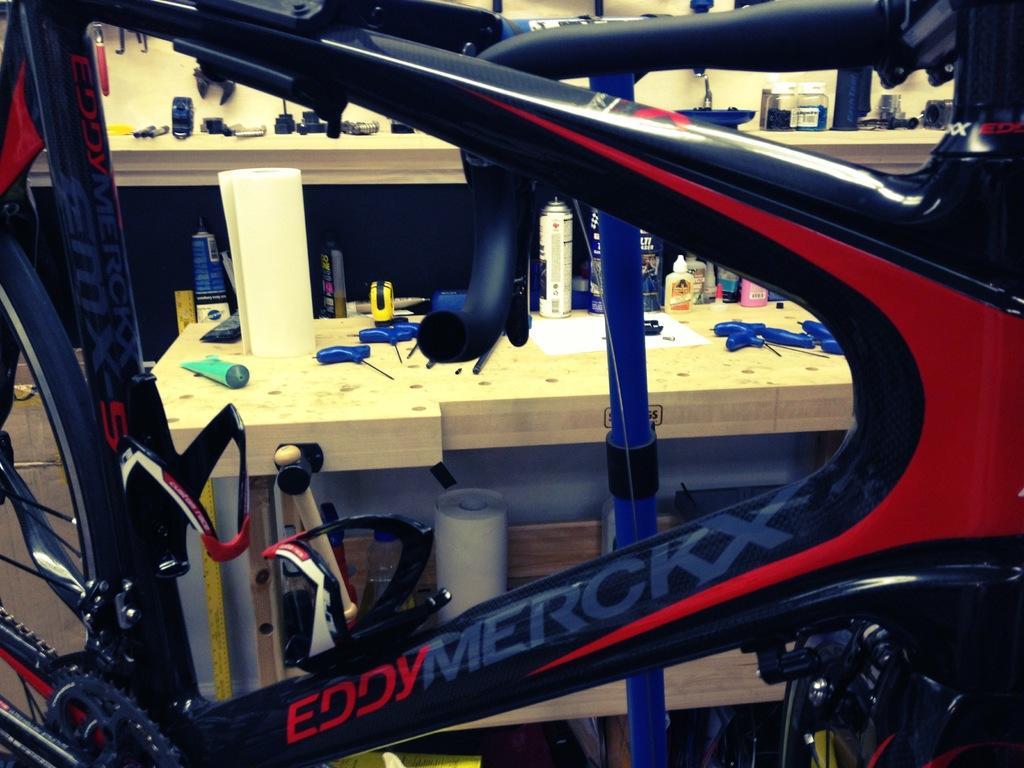Could you give a brief overview of what you see in this image? In this image we can see a bicycle. Behind the bicycle we can see few objects on the tables. 